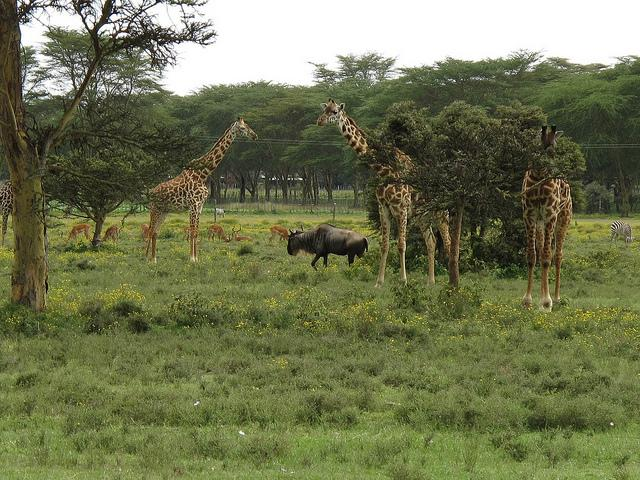How many distinct species of animals are in the field? Please explain your reasoning. four. There are giraffes, deer, a pig and some kind of other animal. 